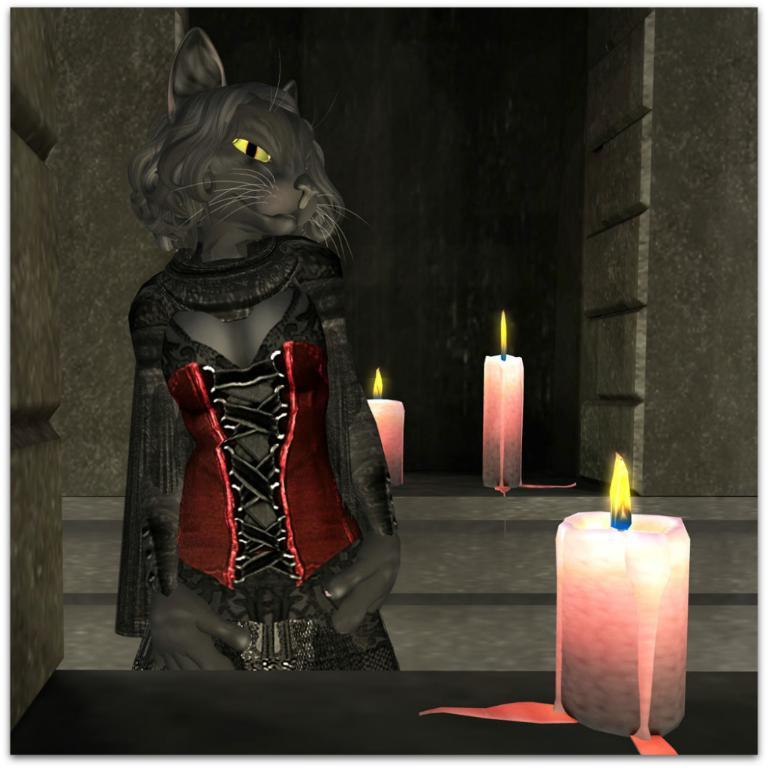What type of cartoon is depicted in the image? There is a cat cartoon in the image. What additional objects can be seen in the image? There are candles in the image. How many pizzas are being painted on the canvas in the image? There are no pizzas or canvas present in the image. What is the theme of the love story depicted in the image? There is no love story depicted in the image; it features a cat cartoon and candles. 